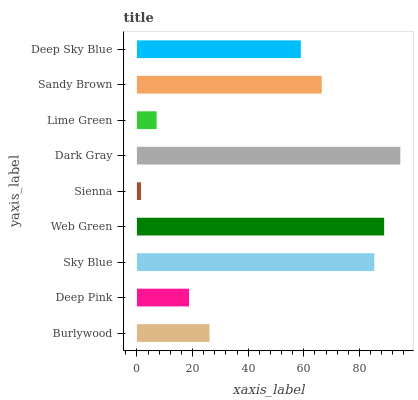Is Sienna the minimum?
Answer yes or no. Yes. Is Dark Gray the maximum?
Answer yes or no. Yes. Is Deep Pink the minimum?
Answer yes or no. No. Is Deep Pink the maximum?
Answer yes or no. No. Is Burlywood greater than Deep Pink?
Answer yes or no. Yes. Is Deep Pink less than Burlywood?
Answer yes or no. Yes. Is Deep Pink greater than Burlywood?
Answer yes or no. No. Is Burlywood less than Deep Pink?
Answer yes or no. No. Is Deep Sky Blue the high median?
Answer yes or no. Yes. Is Deep Sky Blue the low median?
Answer yes or no. Yes. Is Deep Pink the high median?
Answer yes or no. No. Is Sienna the low median?
Answer yes or no. No. 